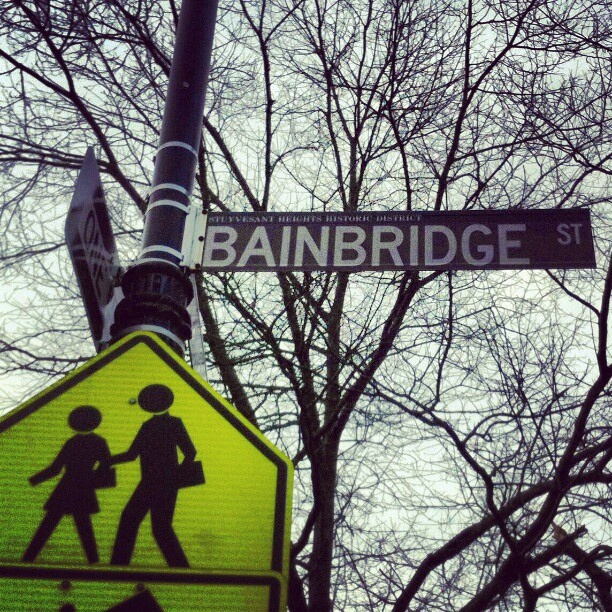Describe the objects in this image and their specific colors. I can see various objects in this image with different colors. 